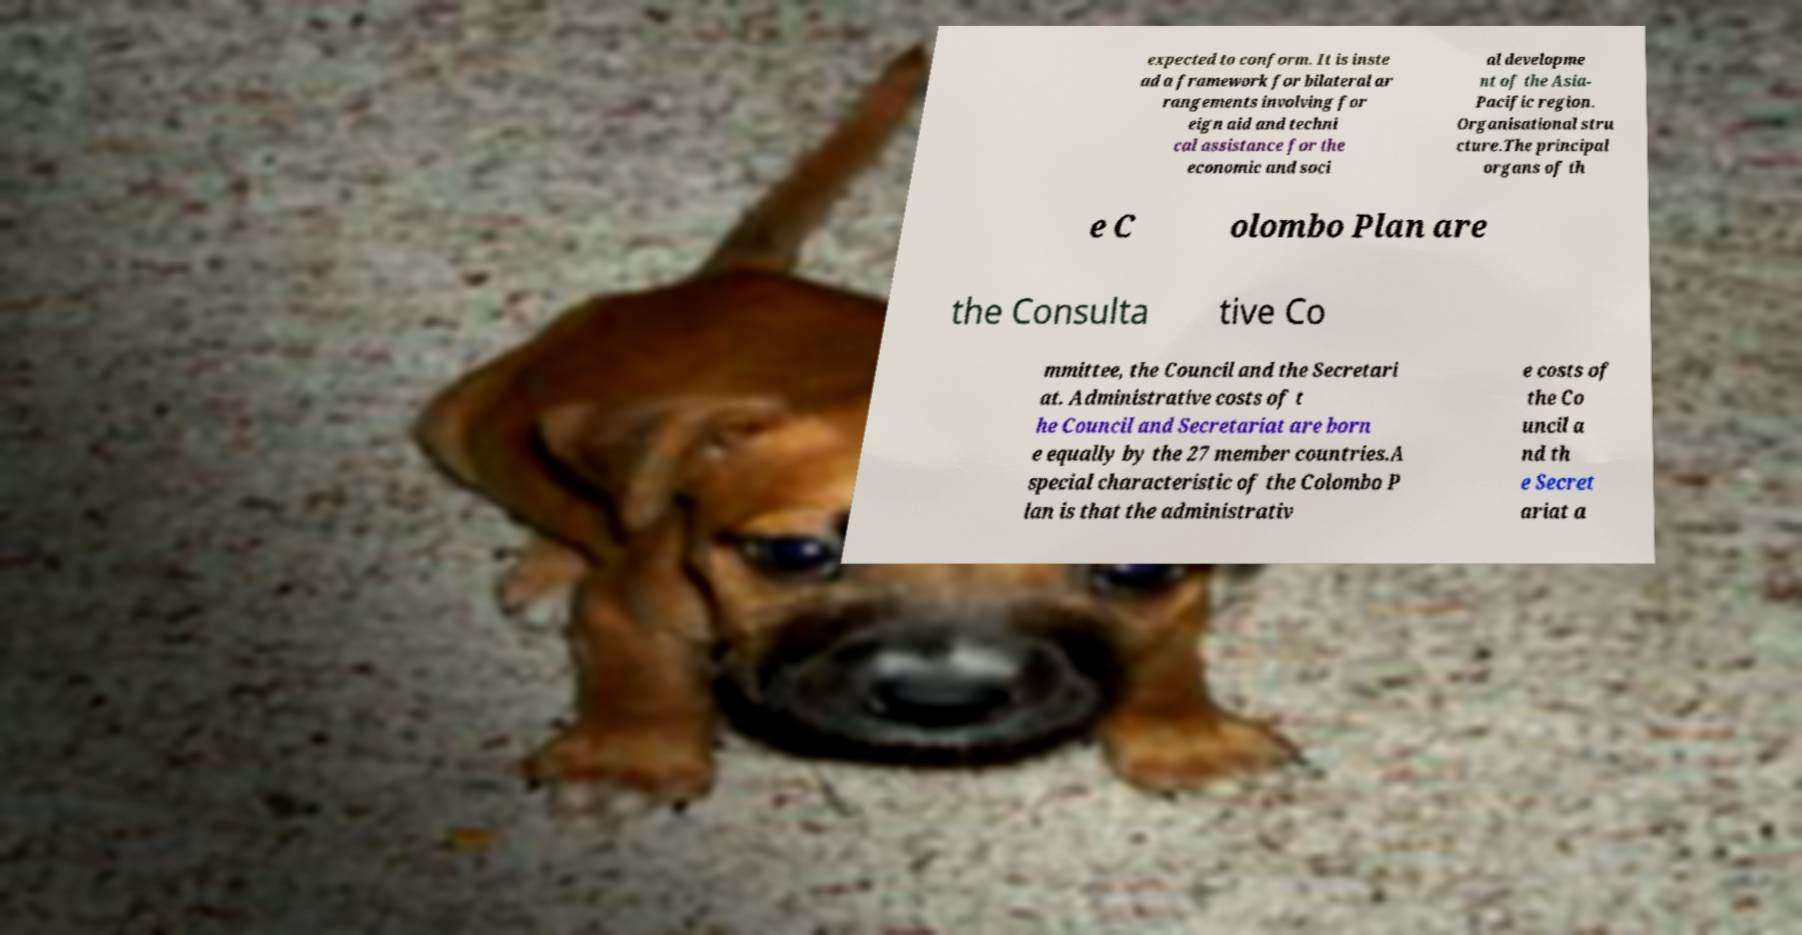For documentation purposes, I need the text within this image transcribed. Could you provide that? expected to conform. It is inste ad a framework for bilateral ar rangements involving for eign aid and techni cal assistance for the economic and soci al developme nt of the Asia- Pacific region. Organisational stru cture.The principal organs of th e C olombo Plan are the Consulta tive Co mmittee, the Council and the Secretari at. Administrative costs of t he Council and Secretariat are born e equally by the 27 member countries.A special characteristic of the Colombo P lan is that the administrativ e costs of the Co uncil a nd th e Secret ariat a 